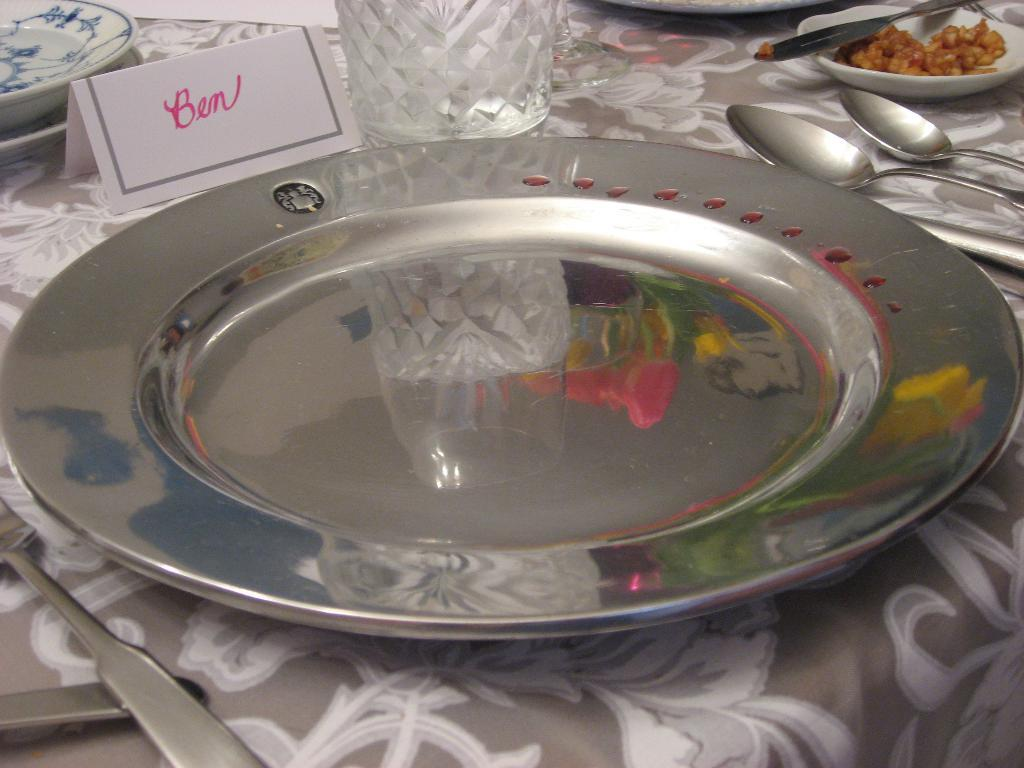What type of furniture is present in the image? There is a table in the image. What is covering the table? There is a cloth on the table. What objects are placed on the cloth? There are plates, spoons, glasses, and bowls on the cloth. Is there any signage or identification on the table? Yes, there is a name board on the table. What hobbies does the person with the face on the name board enjoy? There is no face on the name board, and therefore no information about the person's hobbies can be determined from the image. Why is the fork missing from the table setting in the image? There is no fork mentioned or visible in the image. 